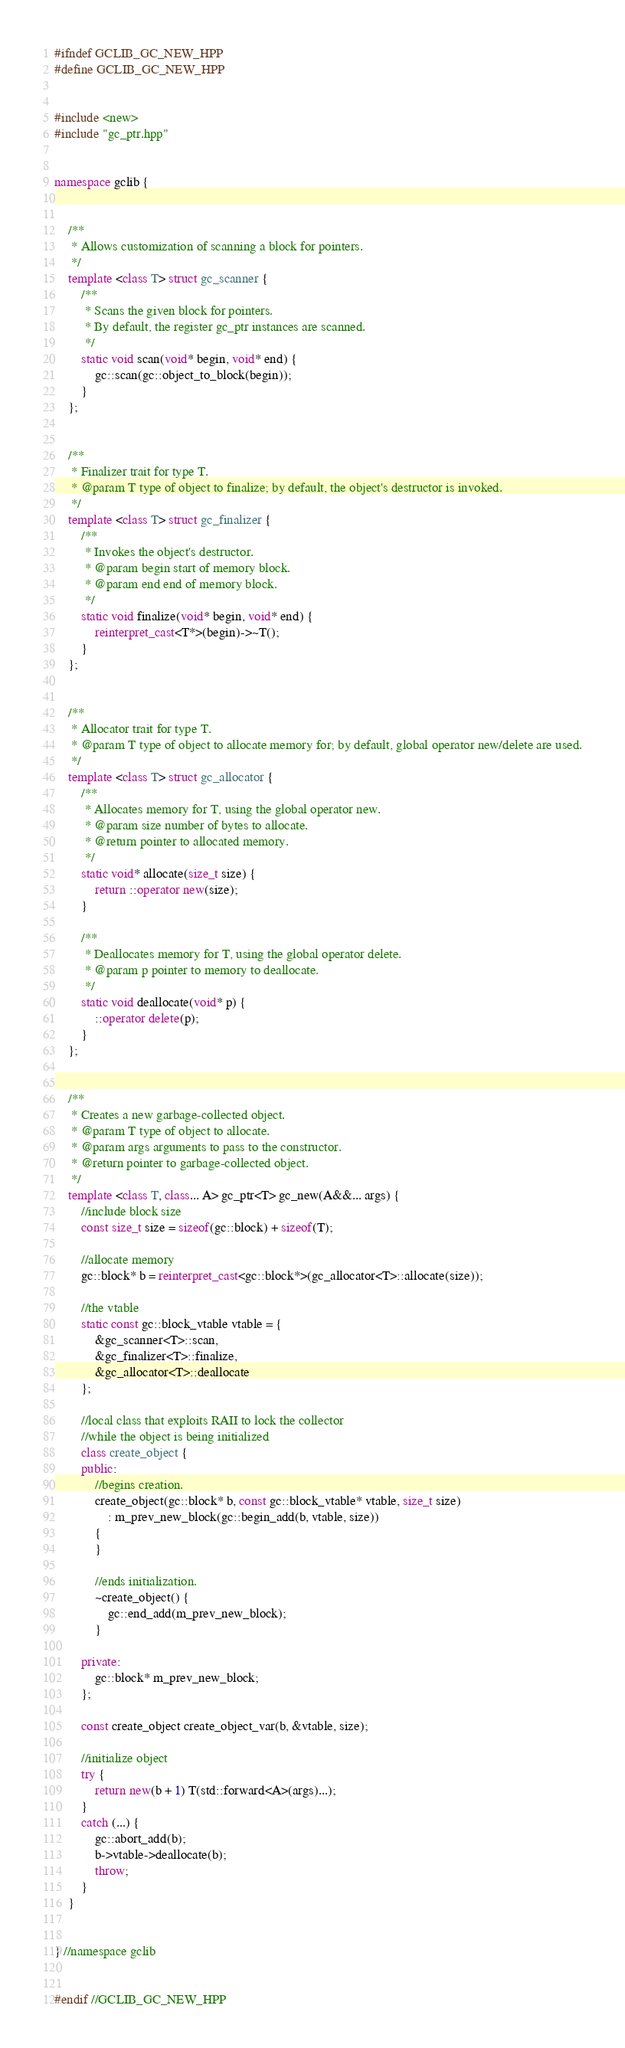Convert code to text. <code><loc_0><loc_0><loc_500><loc_500><_C++_>#ifndef GCLIB_GC_NEW_HPP
#define GCLIB_GC_NEW_HPP


#include <new>
#include "gc_ptr.hpp"


namespace gclib {


    /**
     * Allows customization of scanning a block for pointers.
     */
    template <class T> struct gc_scanner {
        /**
         * Scans the given block for pointers.
         * By default, the register gc_ptr instances are scanned.
         */
        static void scan(void* begin, void* end) {
            gc::scan(gc::object_to_block(begin));
        }
    };


    /**
     * Finalizer trait for type T.
     * @param T type of object to finalize; by default, the object's destructor is invoked.
     */
    template <class T> struct gc_finalizer {
        /**
         * Invokes the object's destructor.
         * @param begin start of memory block.
         * @param end end of memory block.
         */
        static void finalize(void* begin, void* end) {
            reinterpret_cast<T*>(begin)->~T();
        }
    };


    /**
     * Allocator trait for type T.
     * @param T type of object to allocate memory for; by default, global operator new/delete are used.
     */
    template <class T> struct gc_allocator {
        /**
         * Allocates memory for T, using the global operator new.
         * @param size number of bytes to allocate.
         * @return pointer to allocated memory.
         */
        static void* allocate(size_t size) {
            return ::operator new(size);
        }

        /**
         * Deallocates memory for T, using the global operator delete.
         * @param p pointer to memory to deallocate.
         */
        static void deallocate(void* p) {
            ::operator delete(p);
        }
    };


    /**
     * Creates a new garbage-collected object.
     * @param T type of object to allocate.
     * @param args arguments to pass to the constructor.
     * @return pointer to garbage-collected object.
     */
    template <class T, class... A> gc_ptr<T> gc_new(A&&... args) {
        //include block size
        const size_t size = sizeof(gc::block) + sizeof(T);

        //allocate memory
        gc::block* b = reinterpret_cast<gc::block*>(gc_allocator<T>::allocate(size));

        //the vtable
        static const gc::block_vtable vtable = {
            &gc_scanner<T>::scan,
            &gc_finalizer<T>::finalize,
            &gc_allocator<T>::deallocate
        };

        //local class that exploits RAII to lock the collector
        //while the object is being initialized
        class create_object {
        public:
            //begins creation.
            create_object(gc::block* b, const gc::block_vtable* vtable, size_t size)
                : m_prev_new_block(gc::begin_add(b, vtable, size))
            {
            }

            //ends initialization.
            ~create_object() {
                gc::end_add(m_prev_new_block);
            }

        private:
            gc::block* m_prev_new_block;
        };

        const create_object create_object_var(b, &vtable, size);

        //initialize object
        try {
            return new(b + 1) T(std::forward<A>(args)...);
        }
        catch (...) {
            gc::abort_add(b);
            b->vtable->deallocate(b);
            throw;
        }
    }


} //namespace gclib


#endif //GCLIB_GC_NEW_HPP
</code> 